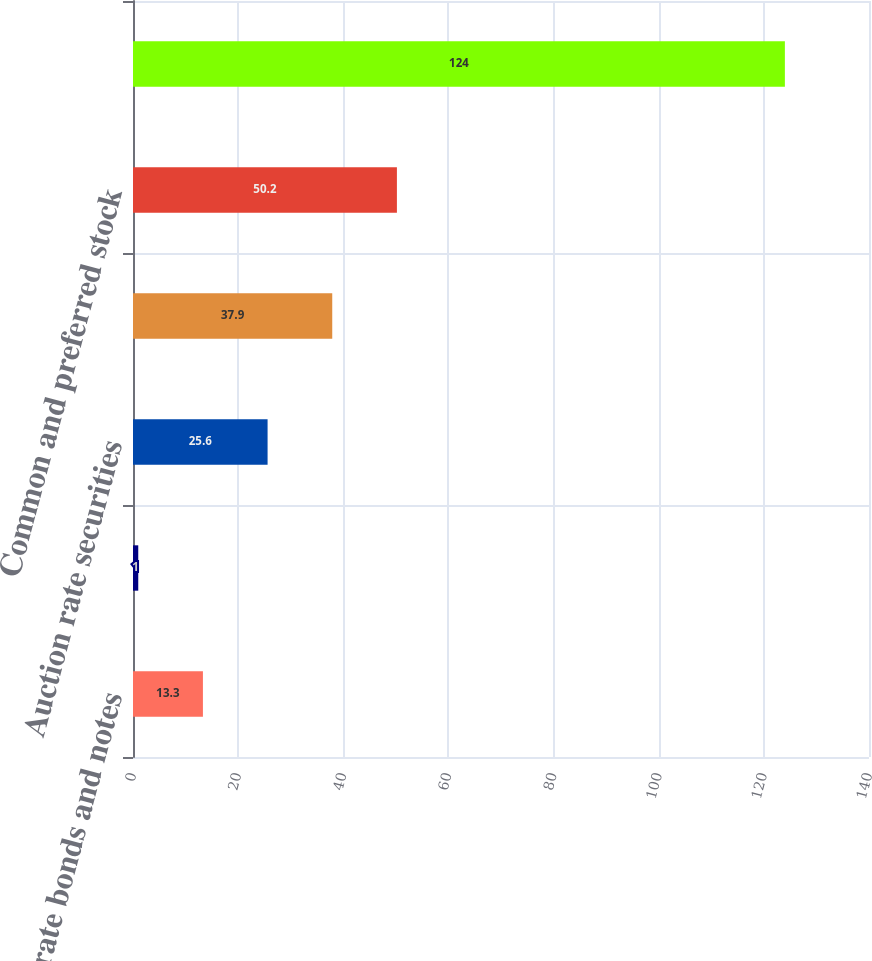<chart> <loc_0><loc_0><loc_500><loc_500><bar_chart><fcel>Corporate bonds and notes<fcel>Mortgage- and asset-backed<fcel>Auction rate securities<fcel>Non-investment-grade debt<fcel>Common and preferred stock<fcel>Equity mutual and<nl><fcel>13.3<fcel>1<fcel>25.6<fcel>37.9<fcel>50.2<fcel>124<nl></chart> 